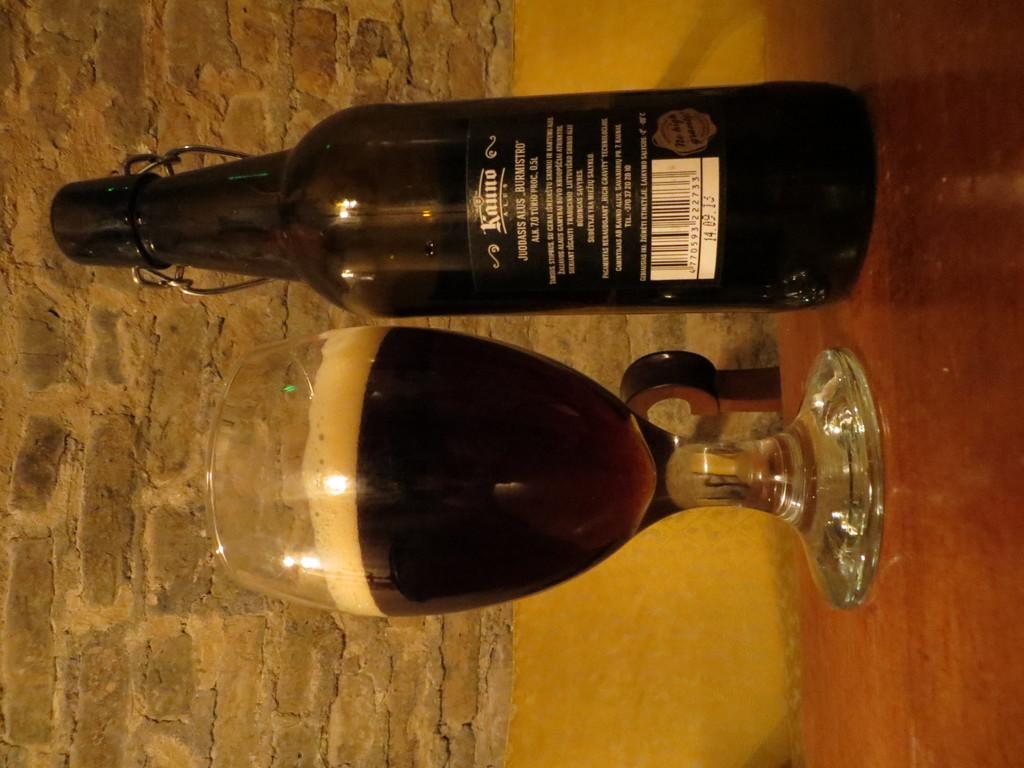<image>
Give a short and clear explanation of the subsequent image. The wine on the table reads as Kunto 